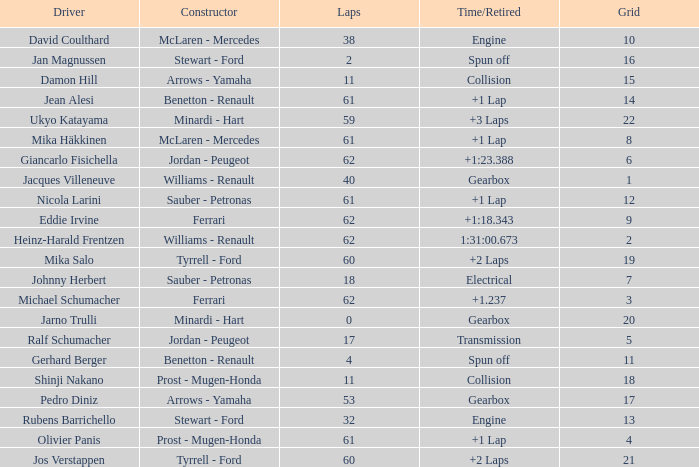What is the time/retired with 60 laps and a grid 19? +2 Laps. Would you be able to parse every entry in this table? {'header': ['Driver', 'Constructor', 'Laps', 'Time/Retired', 'Grid'], 'rows': [['David Coulthard', 'McLaren - Mercedes', '38', 'Engine', '10'], ['Jan Magnussen', 'Stewart - Ford', '2', 'Spun off', '16'], ['Damon Hill', 'Arrows - Yamaha', '11', 'Collision', '15'], ['Jean Alesi', 'Benetton - Renault', '61', '+1 Lap', '14'], ['Ukyo Katayama', 'Minardi - Hart', '59', '+3 Laps', '22'], ['Mika Häkkinen', 'McLaren - Mercedes', '61', '+1 Lap', '8'], ['Giancarlo Fisichella', 'Jordan - Peugeot', '62', '+1:23.388', '6'], ['Jacques Villeneuve', 'Williams - Renault', '40', 'Gearbox', '1'], ['Nicola Larini', 'Sauber - Petronas', '61', '+1 Lap', '12'], ['Eddie Irvine', 'Ferrari', '62', '+1:18.343', '9'], ['Heinz-Harald Frentzen', 'Williams - Renault', '62', '1:31:00.673', '2'], ['Mika Salo', 'Tyrrell - Ford', '60', '+2 Laps', '19'], ['Johnny Herbert', 'Sauber - Petronas', '18', 'Electrical', '7'], ['Michael Schumacher', 'Ferrari', '62', '+1.237', '3'], ['Jarno Trulli', 'Minardi - Hart', '0', 'Gearbox', '20'], ['Ralf Schumacher', 'Jordan - Peugeot', '17', 'Transmission', '5'], ['Gerhard Berger', 'Benetton - Renault', '4', 'Spun off', '11'], ['Shinji Nakano', 'Prost - Mugen-Honda', '11', 'Collision', '18'], ['Pedro Diniz', 'Arrows - Yamaha', '53', 'Gearbox', '17'], ['Rubens Barrichello', 'Stewart - Ford', '32', 'Engine', '13'], ['Olivier Panis', 'Prost - Mugen-Honda', '61', '+1 Lap', '4'], ['Jos Verstappen', 'Tyrrell - Ford', '60', '+2 Laps', '21']]} 